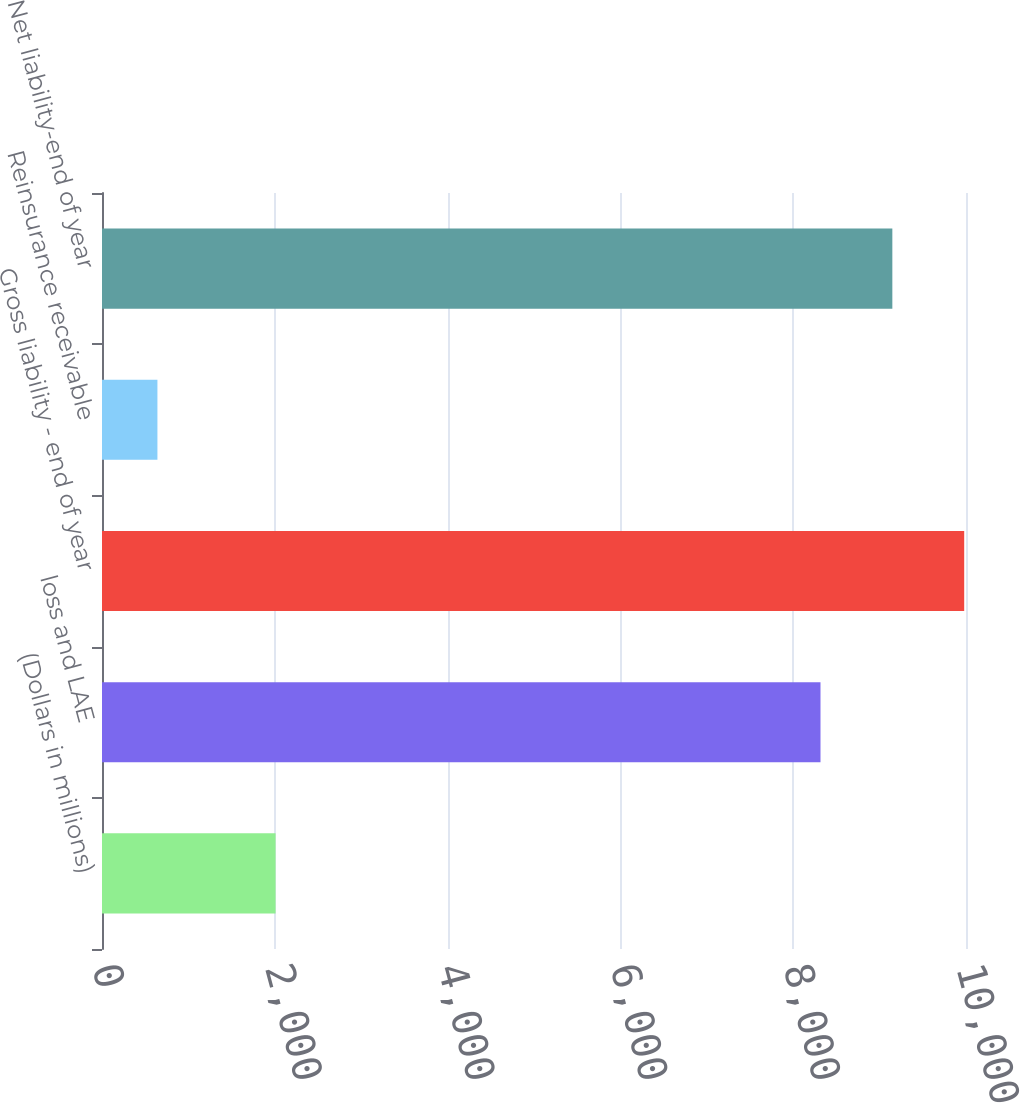<chart> <loc_0><loc_0><loc_500><loc_500><bar_chart><fcel>(Dollars in millions)<fcel>loss and LAE<fcel>Gross liability - end of year<fcel>Reinsurance receivable<fcel>Net liability-end of year<nl><fcel>2009<fcel>8315.9<fcel>9979.08<fcel>641.5<fcel>9147.49<nl></chart> 